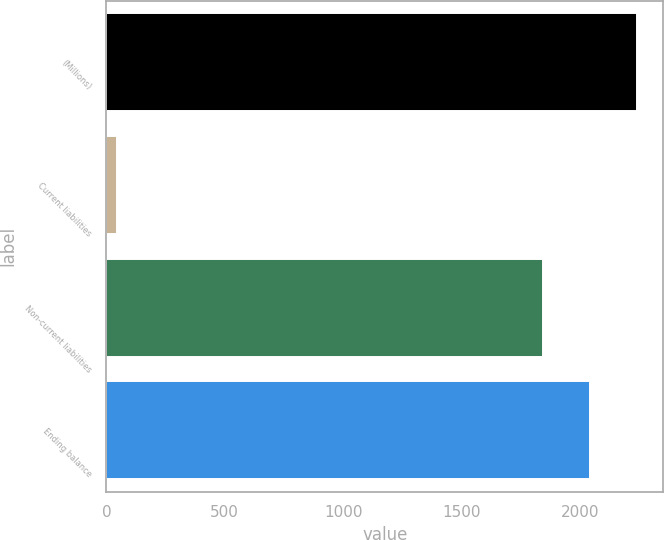Convert chart. <chart><loc_0><loc_0><loc_500><loc_500><bar_chart><fcel>(Millions)<fcel>Current liabilities<fcel>Non-current liabilities<fcel>Ending balance<nl><fcel>2239.6<fcel>47<fcel>1846<fcel>2042.8<nl></chart> 